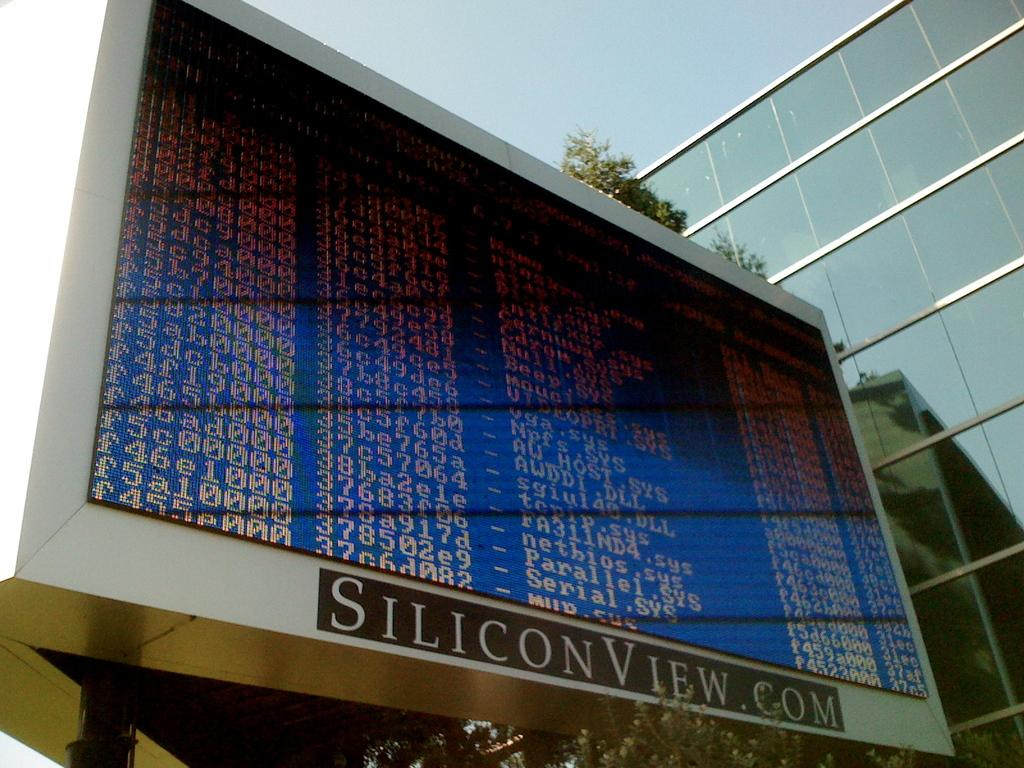What is the main subject in the center of the image? There is a screen with text and numbers in the center of the image. What can be seen in the background of the image? There is a tree and a glass building in the background of the image. What is visible in the sky in the image? The sky is visible in the image. What type of horn can be seen in the field in the image? There is no field or horn present in the image. 